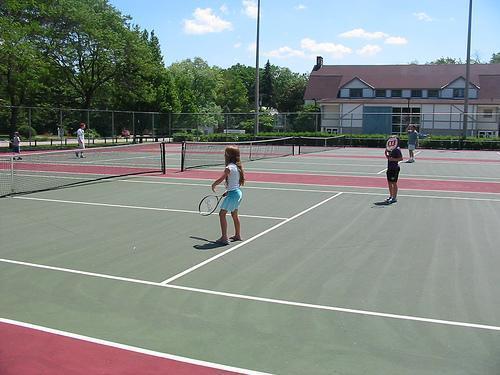How many girls are wearing a white shirt?
Give a very brief answer. 1. 